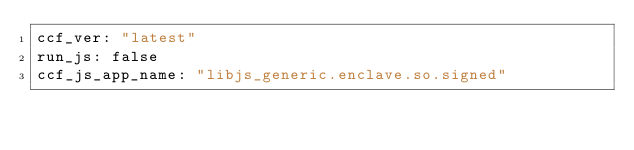<code> <loc_0><loc_0><loc_500><loc_500><_YAML_>ccf_ver: "latest"
run_js: false
ccf_js_app_name: "libjs_generic.enclave.so.signed"
</code> 